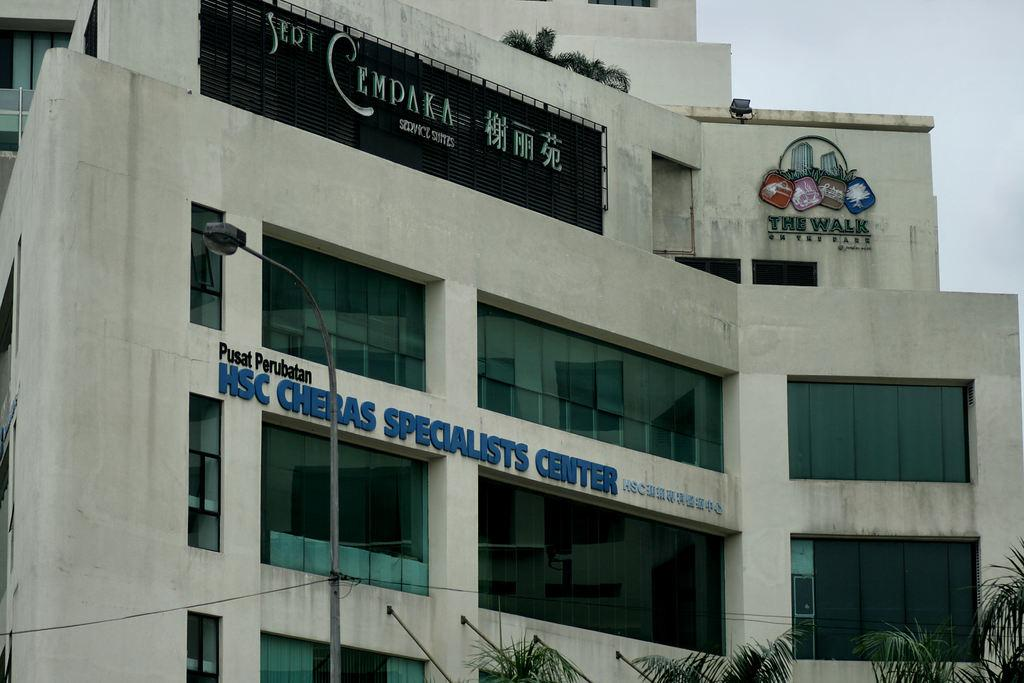What type of structure is visible in the image? There is a building in the image. What other objects can be seen near the building? There is a light pole and wires visible in the image. What can be found on the wall of the building? Texts are written on the wall in the image. Are there any openings in the building? Yes, there are windows in the image. What items are present inside the building? Glasses are present in the image. What type of natural elements are visible in the image? There are trees in the image. What part of the sky is visible in the image? The sky is visible in the image. What type of comb is being used to style the trees in the image? There is no comb present in the image, and the trees are not being styled. 